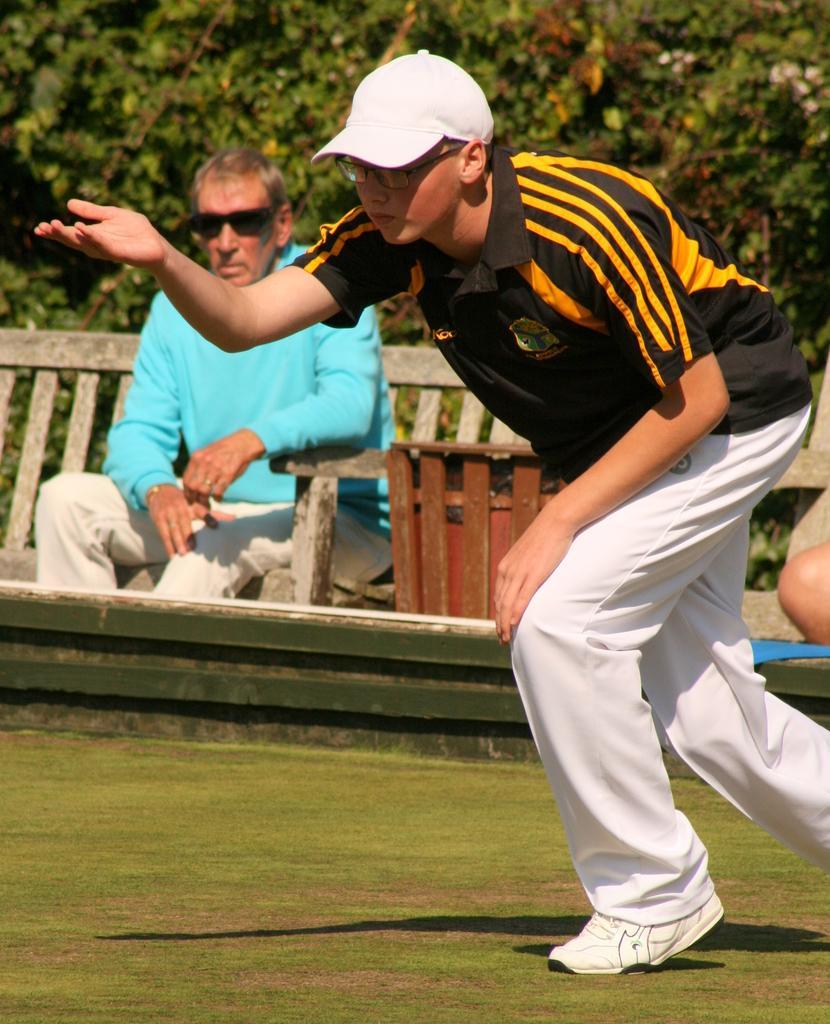How would you summarize this image in a sentence or two? In this image I can see two people with different color dresses. I can see one person is sitting on the bench and another person is standing on the ground and wearing the cap. In the back there are many trees. 